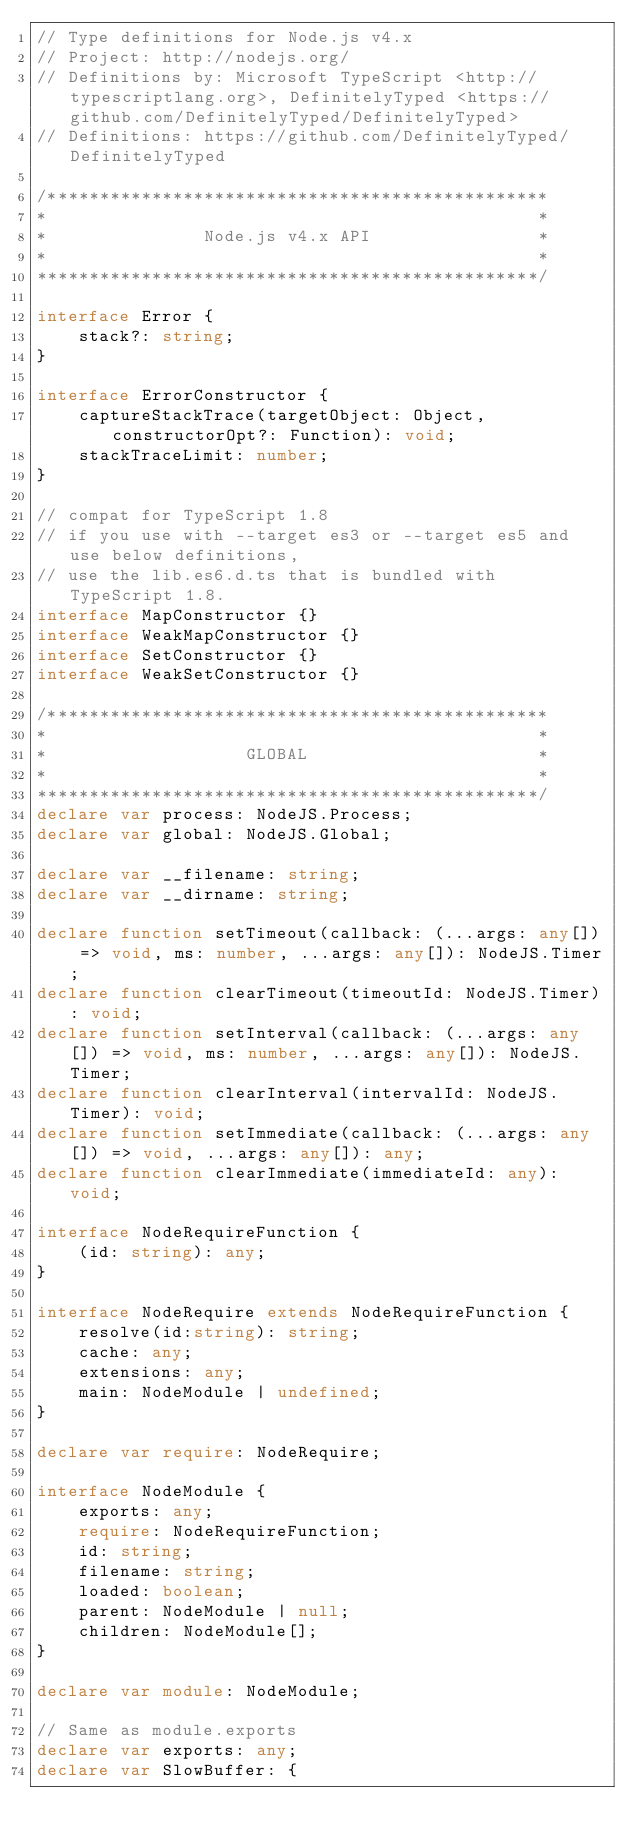<code> <loc_0><loc_0><loc_500><loc_500><_TypeScript_>// Type definitions for Node.js v4.x
// Project: http://nodejs.org/
// Definitions by: Microsoft TypeScript <http://typescriptlang.org>, DefinitelyTyped <https://github.com/DefinitelyTyped/DefinitelyTyped>
// Definitions: https://github.com/DefinitelyTyped/DefinitelyTyped

/************************************************
*                                               *
*               Node.js v4.x API                *
*                                               *
************************************************/

interface Error {
    stack?: string;
}

interface ErrorConstructor {
    captureStackTrace(targetObject: Object, constructorOpt?: Function): void;
    stackTraceLimit: number;
}

// compat for TypeScript 1.8
// if you use with --target es3 or --target es5 and use below definitions,
// use the lib.es6.d.ts that is bundled with TypeScript 1.8.
interface MapConstructor {}
interface WeakMapConstructor {}
interface SetConstructor {}
interface WeakSetConstructor {}

/************************************************
*                                               *
*                   GLOBAL                      *
*                                               *
************************************************/
declare var process: NodeJS.Process;
declare var global: NodeJS.Global;

declare var __filename: string;
declare var __dirname: string;

declare function setTimeout(callback: (...args: any[]) => void, ms: number, ...args: any[]): NodeJS.Timer;
declare function clearTimeout(timeoutId: NodeJS.Timer): void;
declare function setInterval(callback: (...args: any[]) => void, ms: number, ...args: any[]): NodeJS.Timer;
declare function clearInterval(intervalId: NodeJS.Timer): void;
declare function setImmediate(callback: (...args: any[]) => void, ...args: any[]): any;
declare function clearImmediate(immediateId: any): void;

interface NodeRequireFunction {
    (id: string): any;
}

interface NodeRequire extends NodeRequireFunction {
    resolve(id:string): string;
    cache: any;
    extensions: any;
    main: NodeModule | undefined;
}

declare var require: NodeRequire;

interface NodeModule {
    exports: any;
    require: NodeRequireFunction;
    id: string;
    filename: string;
    loaded: boolean;
    parent: NodeModule | null;
    children: NodeModule[];
}

declare var module: NodeModule;

// Same as module.exports
declare var exports: any;
declare var SlowBuffer: {</code> 